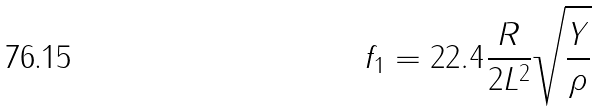Convert formula to latex. <formula><loc_0><loc_0><loc_500><loc_500>f _ { 1 } = 2 2 . 4 \frac { R } { 2 L ^ { 2 } } \sqrt { \frac { Y } { \rho } }</formula> 